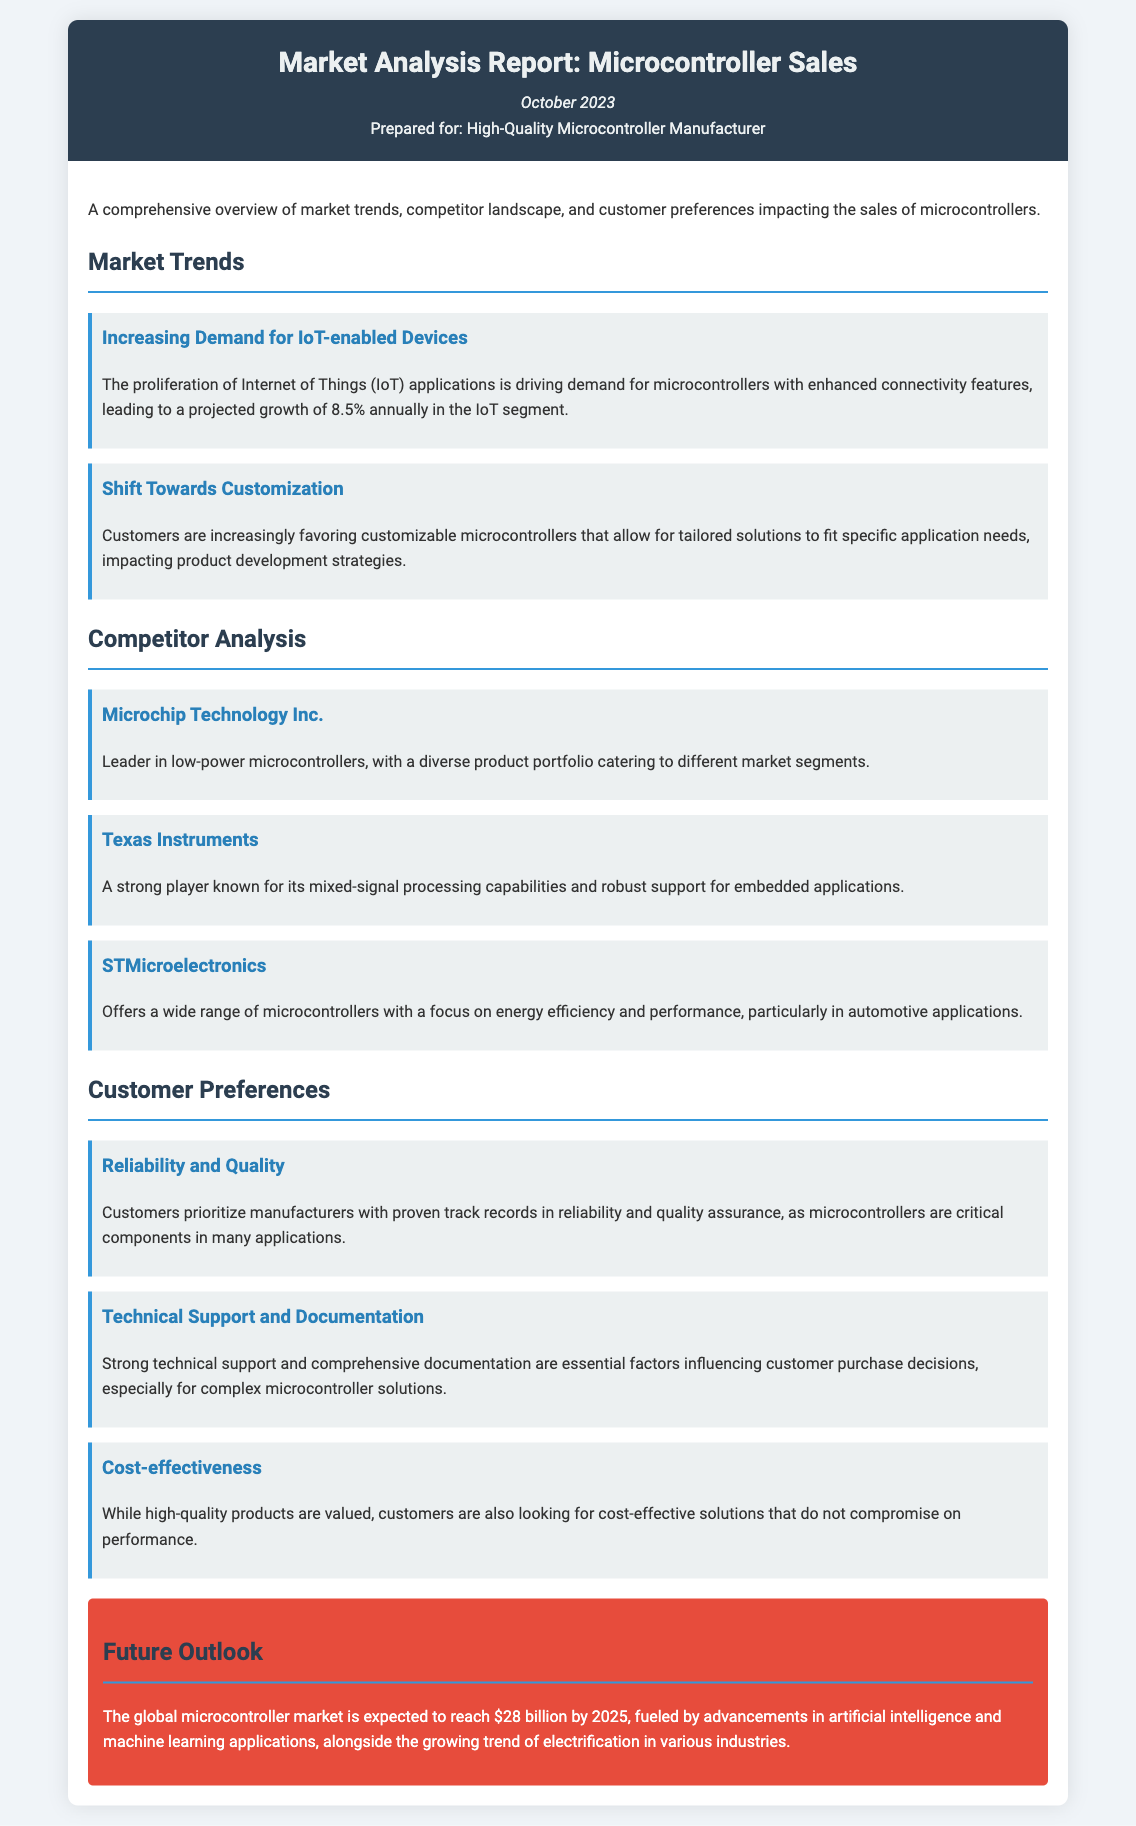What is the projected annual growth rate in the IoT segment? The document states that the projected growth of the IoT segment is 8.5% annually.
Answer: 8.5% Which company is noted as a leader in low-power microcontrollers? Microchip Technology Inc. is identified as the leader in low-power microcontrollers.
Answer: Microchip Technology Inc What customer preference is described as prioritizing manufacturers with proven track records? The preference for reliability and quality indicates that customers prioritize proven manufacturers.
Answer: Reliability and Quality What is a key factor influencing customer purchase decisions for complex microcontroller solutions? Strong technical support and comprehensive documentation are essential for customer purchase decisions.
Answer: Technical Support and Documentation What is the expected value of the global microcontroller market by 2025? The report mentions that the global microcontroller market is expected to reach $28 billion by 2025.
Answer: $28 billion What trend is driving demand for customizable microcontrollers? The shift towards customization is driving demand for tailored solutions in microcontrollers.
Answer: Customization Which company is known for its mixed-signal processing capabilities? Texas Instruments is recognized for its mixed-signal processing capabilities.
Answer: Texas Instruments What are customers looking for in addition to high-quality products? Customers are also looking for cost-effective solutions alongside high-quality products.
Answer: Cost-effectiveness 